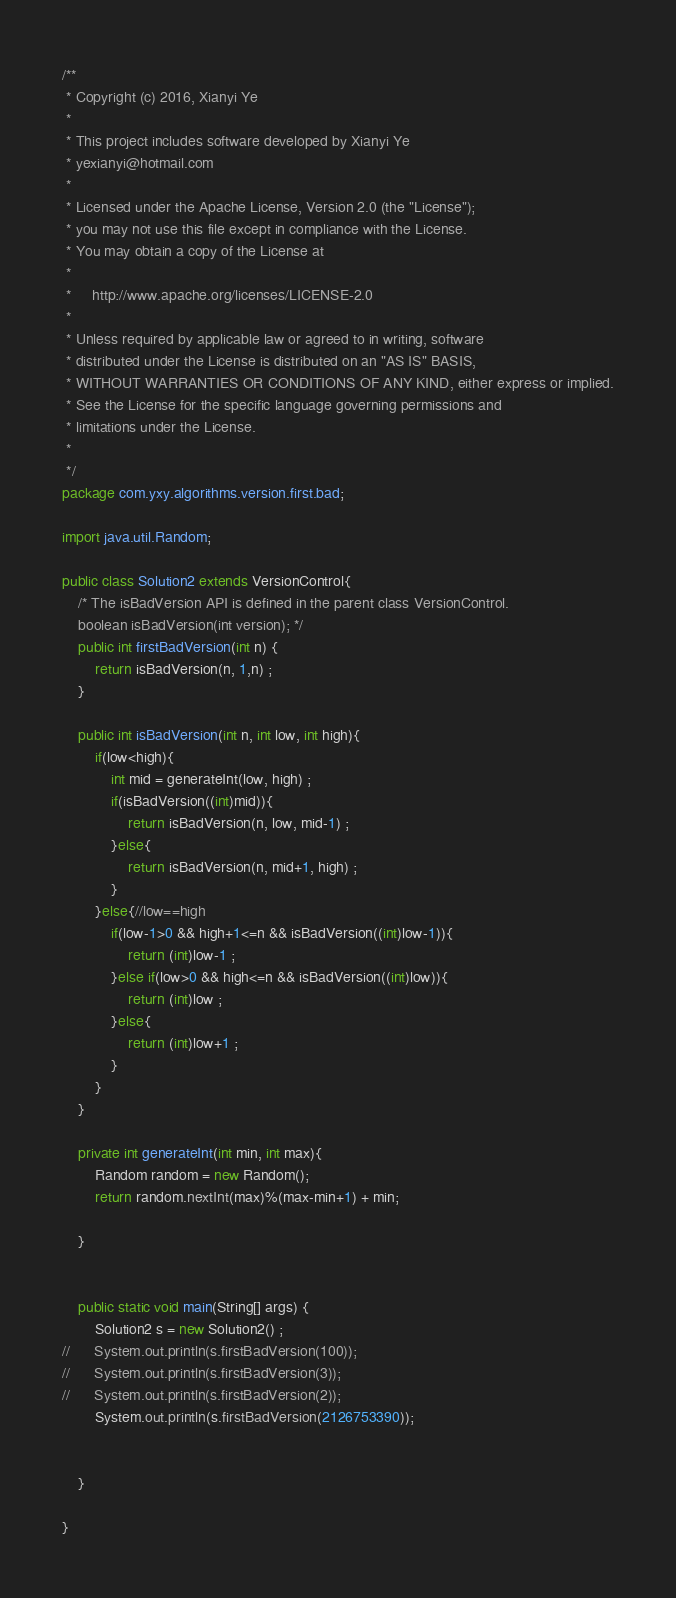<code> <loc_0><loc_0><loc_500><loc_500><_Java_>/**
 * Copyright (c) 2016, Xianyi Ye
 *
 * This project includes software developed by Xianyi Ye
 * yexianyi@hotmail.com
 *
 * Licensed under the Apache License, Version 2.0 (the "License");
 * you may not use this file except in compliance with the License.
 * You may obtain a copy of the License at
 *
 *     http://www.apache.org/licenses/LICENSE-2.0
 *
 * Unless required by applicable law or agreed to in writing, software
 * distributed under the License is distributed on an "AS IS" BASIS,
 * WITHOUT WARRANTIES OR CONDITIONS OF ANY KIND, either express or implied.
 * See the License for the specific language governing permissions and
 * limitations under the License.
 *
 */
package com.yxy.algorithms.version.first.bad;

import java.util.Random;

public class Solution2 extends VersionControl{
	/* The isBadVersion API is defined in the parent class VersionControl.
    boolean isBadVersion(int version); */
	public int firstBadVersion(int n) {
		return isBadVersion(n, 1,n) ;
    }
	
	public int isBadVersion(int n, int low, int high){
		if(low<high){
			int mid = generateInt(low, high) ;
			if(isBadVersion((int)mid)){
				return isBadVersion(n, low, mid-1) ;
			}else{
				return isBadVersion(n, mid+1, high) ;
			}
		}else{//low==high
			if(low-1>0 && high+1<=n && isBadVersion((int)low-1)){
				return (int)low-1 ;
			}else if(low>0 && high<=n && isBadVersion((int)low)){
				return (int)low ;
			}else{
				return (int)low+1 ;
			}
		}
	}
	
	private int generateInt(int min, int max){
		Random random = new Random();
		return random.nextInt(max)%(max-min+1) + min;
		
	}


	public static void main(String[] args) {
		Solution2 s = new Solution2() ;
//		System.out.println(s.firstBadVersion(100));
//		System.out.println(s.firstBadVersion(3));
//		System.out.println(s.firstBadVersion(2));
		System.out.println(s.firstBadVersion(2126753390));
	    

	}

}
</code> 